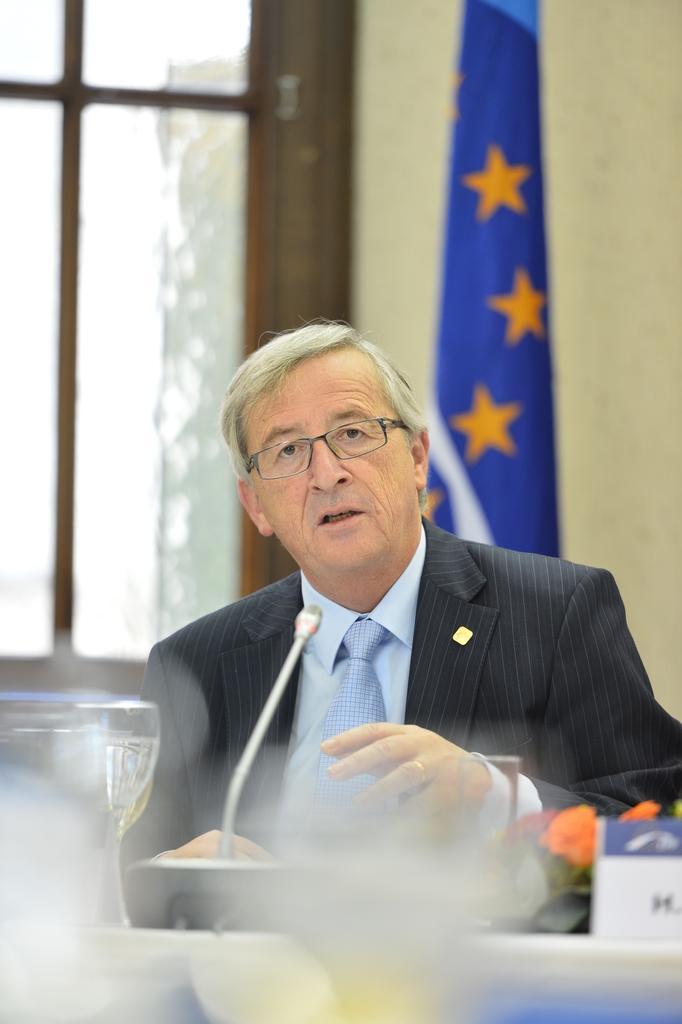How would you summarize this image in a sentence or two? This is the man sitting and speaking. He wore a suit, shirt, tie and spectacles. This looks like a table with a name board, flower bouquet, water glass and a mike. This looks like a flag hanging. I think this is the window with a glass door. 